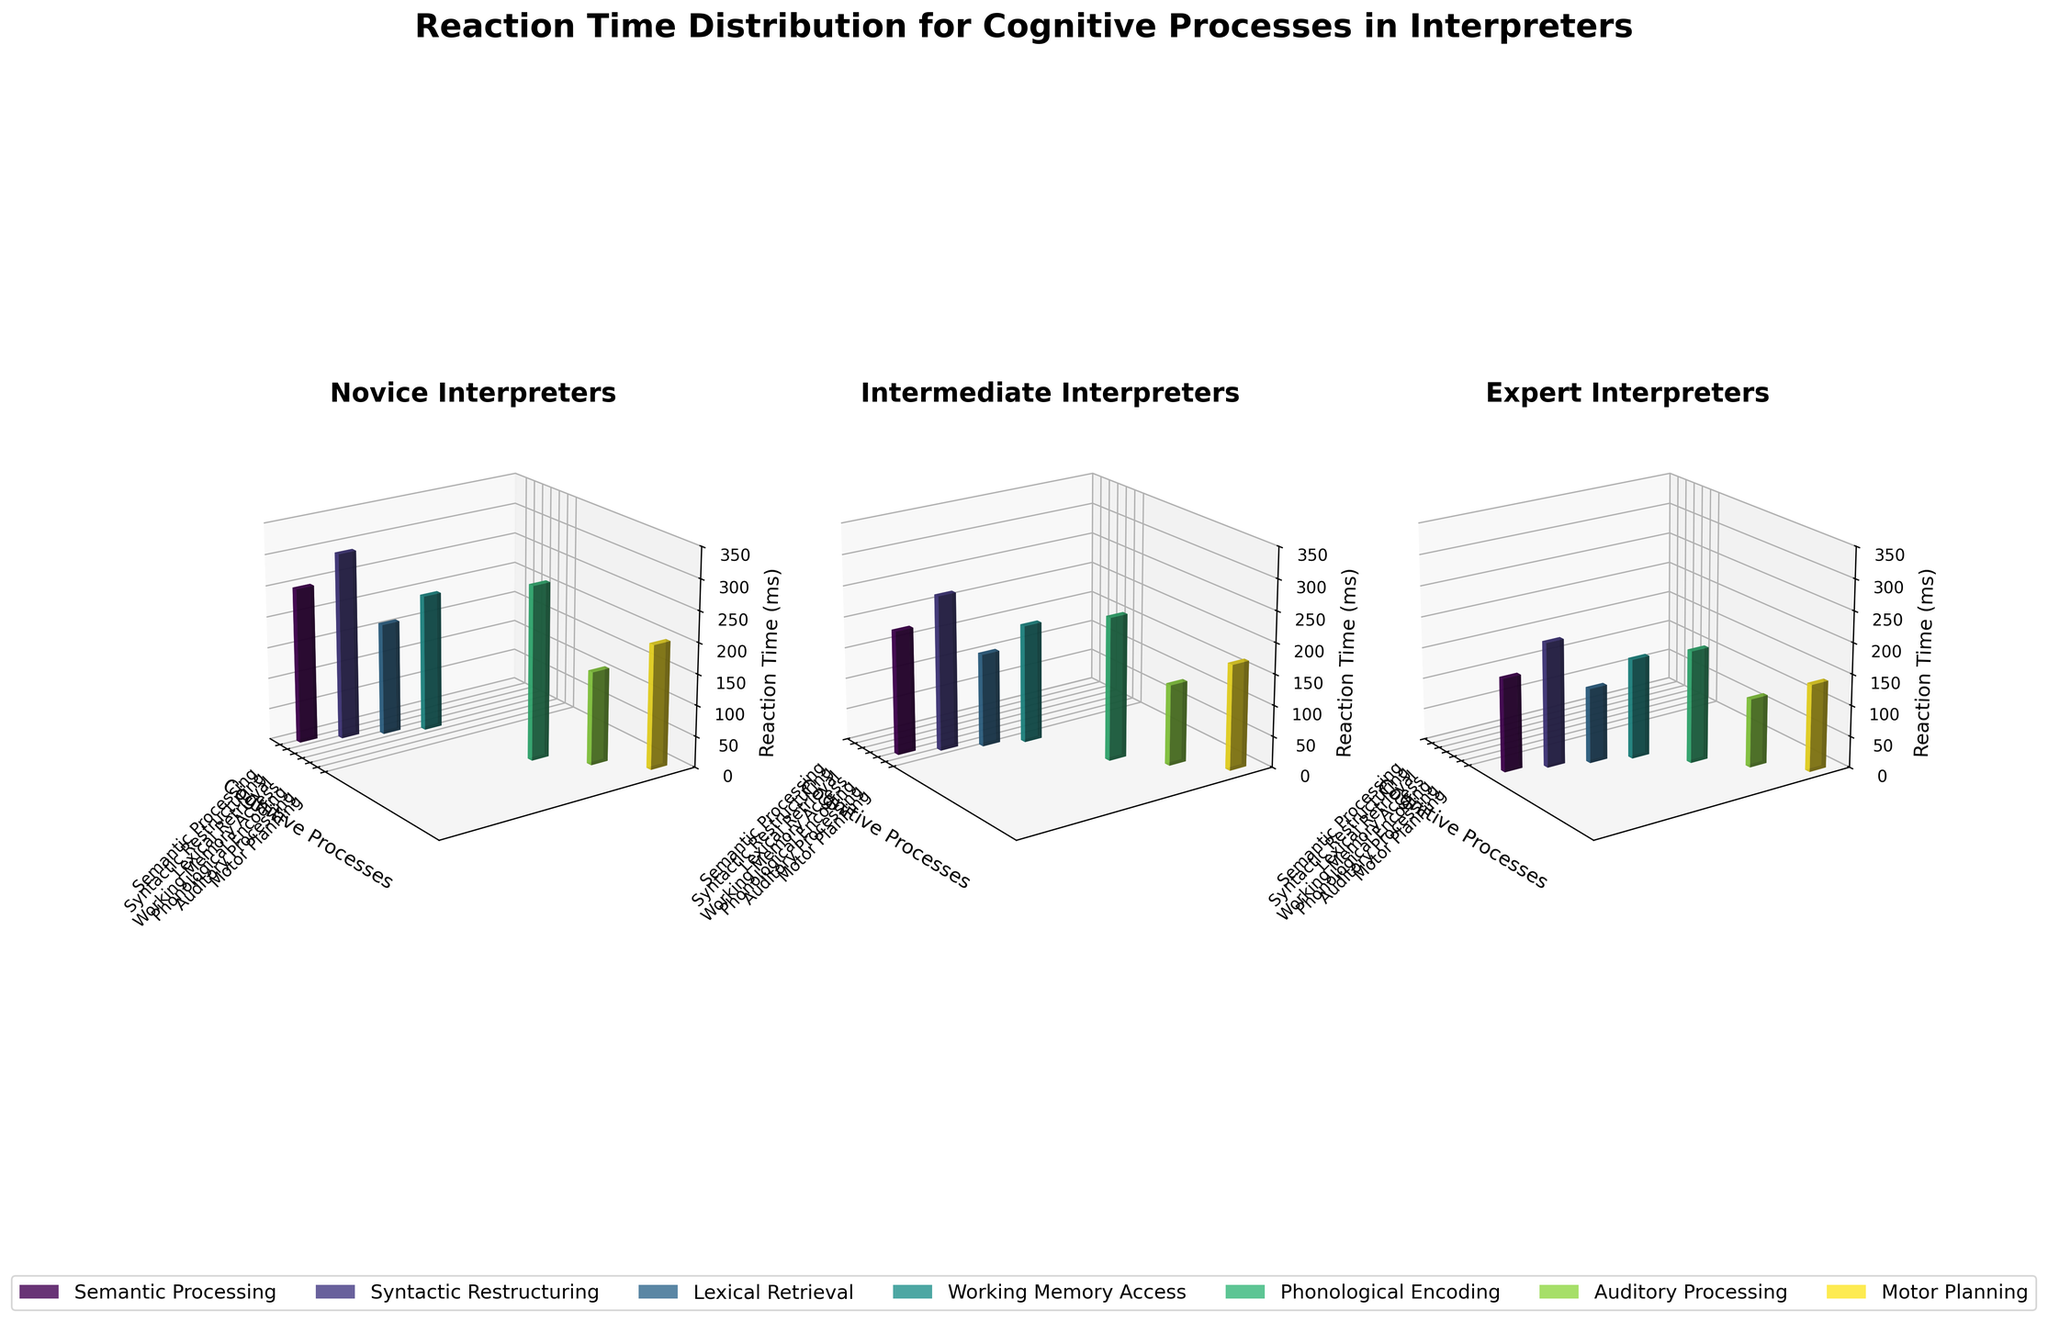What is the title of the figure? The title of the figure can be found at the top center of the plot. It reads "Reaction Time Distribution for Cognitive Processes in Interpreters."
Answer: Reaction Time Distribution for Cognitive Processes in Interpreters Which cognitive process has the highest reaction time for novice interpreters? Looking at the "Novice Interpreters" subplot, the tallest bar is for "Phonological Encoding," indicating that it has the highest reaction time.
Answer: Phonological Encoding How does the reaction time for semantic processing compare between novice and expert interpreters? In their respective subplots, the reaction time for "Semantic Processing" is higher for novice interpreters (250 ms) compared to expert interpreters (150 ms).
Answer: Novice interpreters have a higher reaction time What is the experience level with the lowest reaction time for auditory processing? Looking at the "Auditory Processing" section across all three subplots, expert interpreters have the lowest reaction time (110 ms) compared to intermediate (130 ms) and novice (150 ms).
Answer: Expert Which cognitive process shows the most considerable decrease in reaction time from novice to expert interpreters? From examining the subplots for each experience level, "Semantic Processing" shows the most considerable decrease, from 250 ms (novice) to 150 ms (expert), a total decrease of 100 ms.
Answer: Semantic Processing What is the range of reaction times for motor planning across all experience levels? The reaction times for "Motor Planning" are 200 ms (novice), 170 ms (intermediate), and 140 ms (expert). The range is the difference between the highest and lowest values: 200 - 140 = 60 ms.
Answer: 60 ms How many cognitive processes are analyzed in the figure? There are vertical bars corresponding to the cognitive processes in each subplot. Counting the unique labels on the x-axis, there are six cognitive processes.
Answer: Six What is the average reaction time for syntactic restructuring across all experience levels? The reaction times for "Syntactic Restructuring" are 300 ms (novice), 250 ms (intermediate), and 200 ms (expert). The average is calculated as (300 + 250 + 200) / 3 = 750 / 3 = 250 ms.
Answer: 250 ms Which cognitive process is represented by the color closest to yellow? The specific color can be identified in the legend provided at the bottom. The color closest to yellow represents "Auditory Processing."
Answer: Auditory Processing 